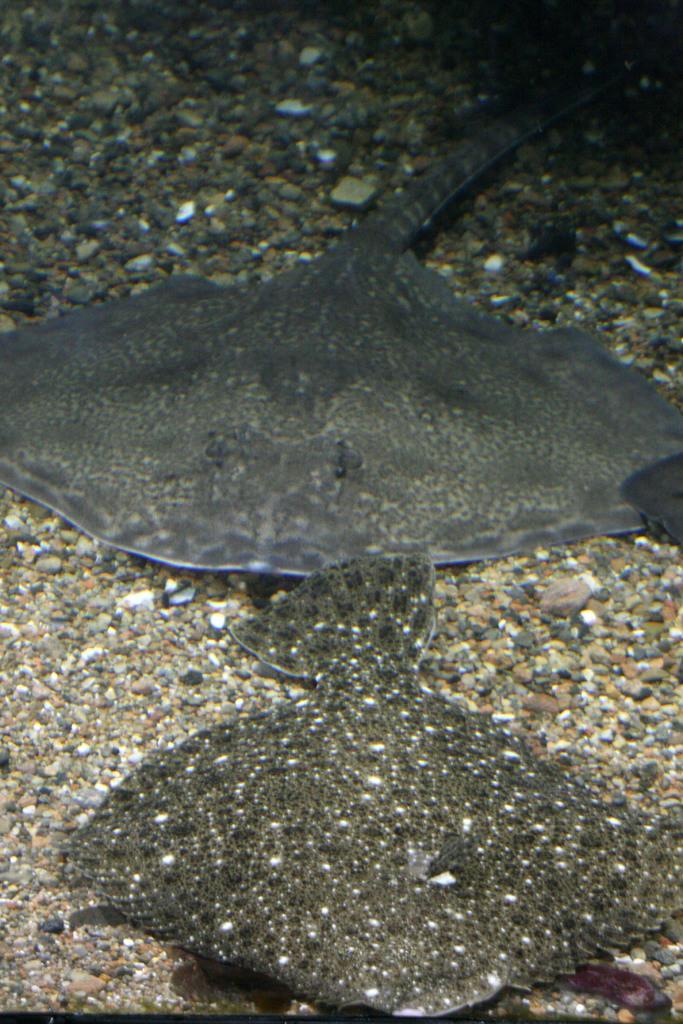Describe this image in one or two sentences. In the image I can see fishes, stones and some other objects. 